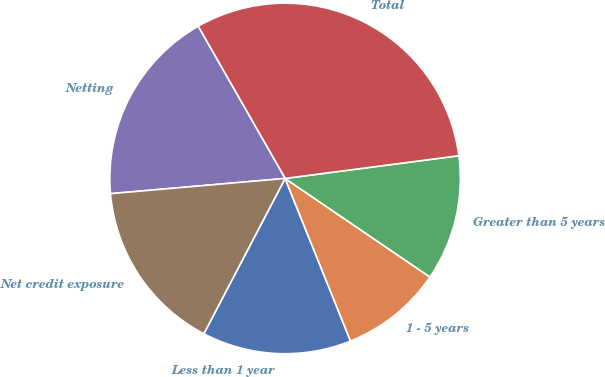<chart> <loc_0><loc_0><loc_500><loc_500><pie_chart><fcel>Less than 1 year<fcel>1 - 5 years<fcel>Greater than 5 years<fcel>Total<fcel>Netting<fcel>Net credit exposure<nl><fcel>13.76%<fcel>9.4%<fcel>11.58%<fcel>31.19%<fcel>18.12%<fcel>15.94%<nl></chart> 